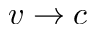Convert formula to latex. <formula><loc_0><loc_0><loc_500><loc_500>v \rightarrow c</formula> 